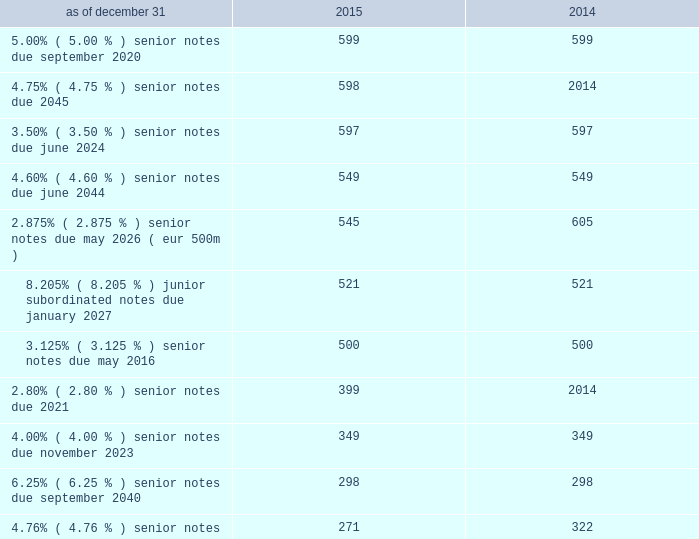Debt the following is a summary of outstanding debt ( in millions ) : .
Revolving credit facilities as of december 31 , 2015 , aon plc had two committed credit facilities outstanding : its $ 400 million u.s .
Credit facility expiring in march 2017 ( the "2017 facility" ) and $ 900 million multi-currency u.s .
Credit facility expiring in february 2020 ( the "2020 facility" ) .
The 2020 facility was entered into on february 2 , 2015 and replaced the previous 20ac650 million european credit facility .
Effective february 2 , 2016 , the 2020 facility terms were extended for 1 year and will expire in february 2021 .
Each of these facilities included customary representations , warranties and covenants , including financial covenants that require aon plc to maintain specified ratios of adjusted consolidated ebitda to consolidated interest expense and consolidated debt to adjusted consolidated ebitda , in each case , tested quarterly .
At december 31 , 2015 , aon plc did not have borrowings under either the 2017 facility or the 2020 facility , and was in compliance with these financial covenants and all other covenants contained therein during the twelve months ended december 31 , 2015 .
On november 13 , 2015 , aon plc issued $ 400 million of 2.80% ( 2.80 % ) senior notes due march 2021 .
We used the proceeds of the issuance for general corporate purposes .
On september 30 , 2015 , $ 600 million of 3.50% ( 3.50 % ) senior notes issued by aon corporation matured and were repaid .
On may 20 , 2015 , the aon plc issued $ 600 million of 4.750% ( 4.750 % ) senior notes due may 2045 .
The company used the proceeds of the issuance for general corporate purposes .
On august 12 , 2014 , aon plc issued $ 350 million of 3.50% ( 3.50 % ) senior notes due june 2024 .
The 3.50% ( 3.50 % ) notes due 2024 constitute a further issuance of , and were consolidated to form a single series of debt securities with , the $ 250 million of 3.50% ( 3.50 % ) notes due june 2024 that was issued by aon plc on may 20 , 2014 concurrently with aon plc's issuance of $ 550 million of 4.60% ( 4.60 % ) notes due june 2044 .
Aon plc used the proceeds from these issuances for working capital and general corporate purposes. .
What portion of the total debt is reported under current liabilities section as of december 31 , 2015? 
Computations: (562 / 5737)
Answer: 0.09796. 